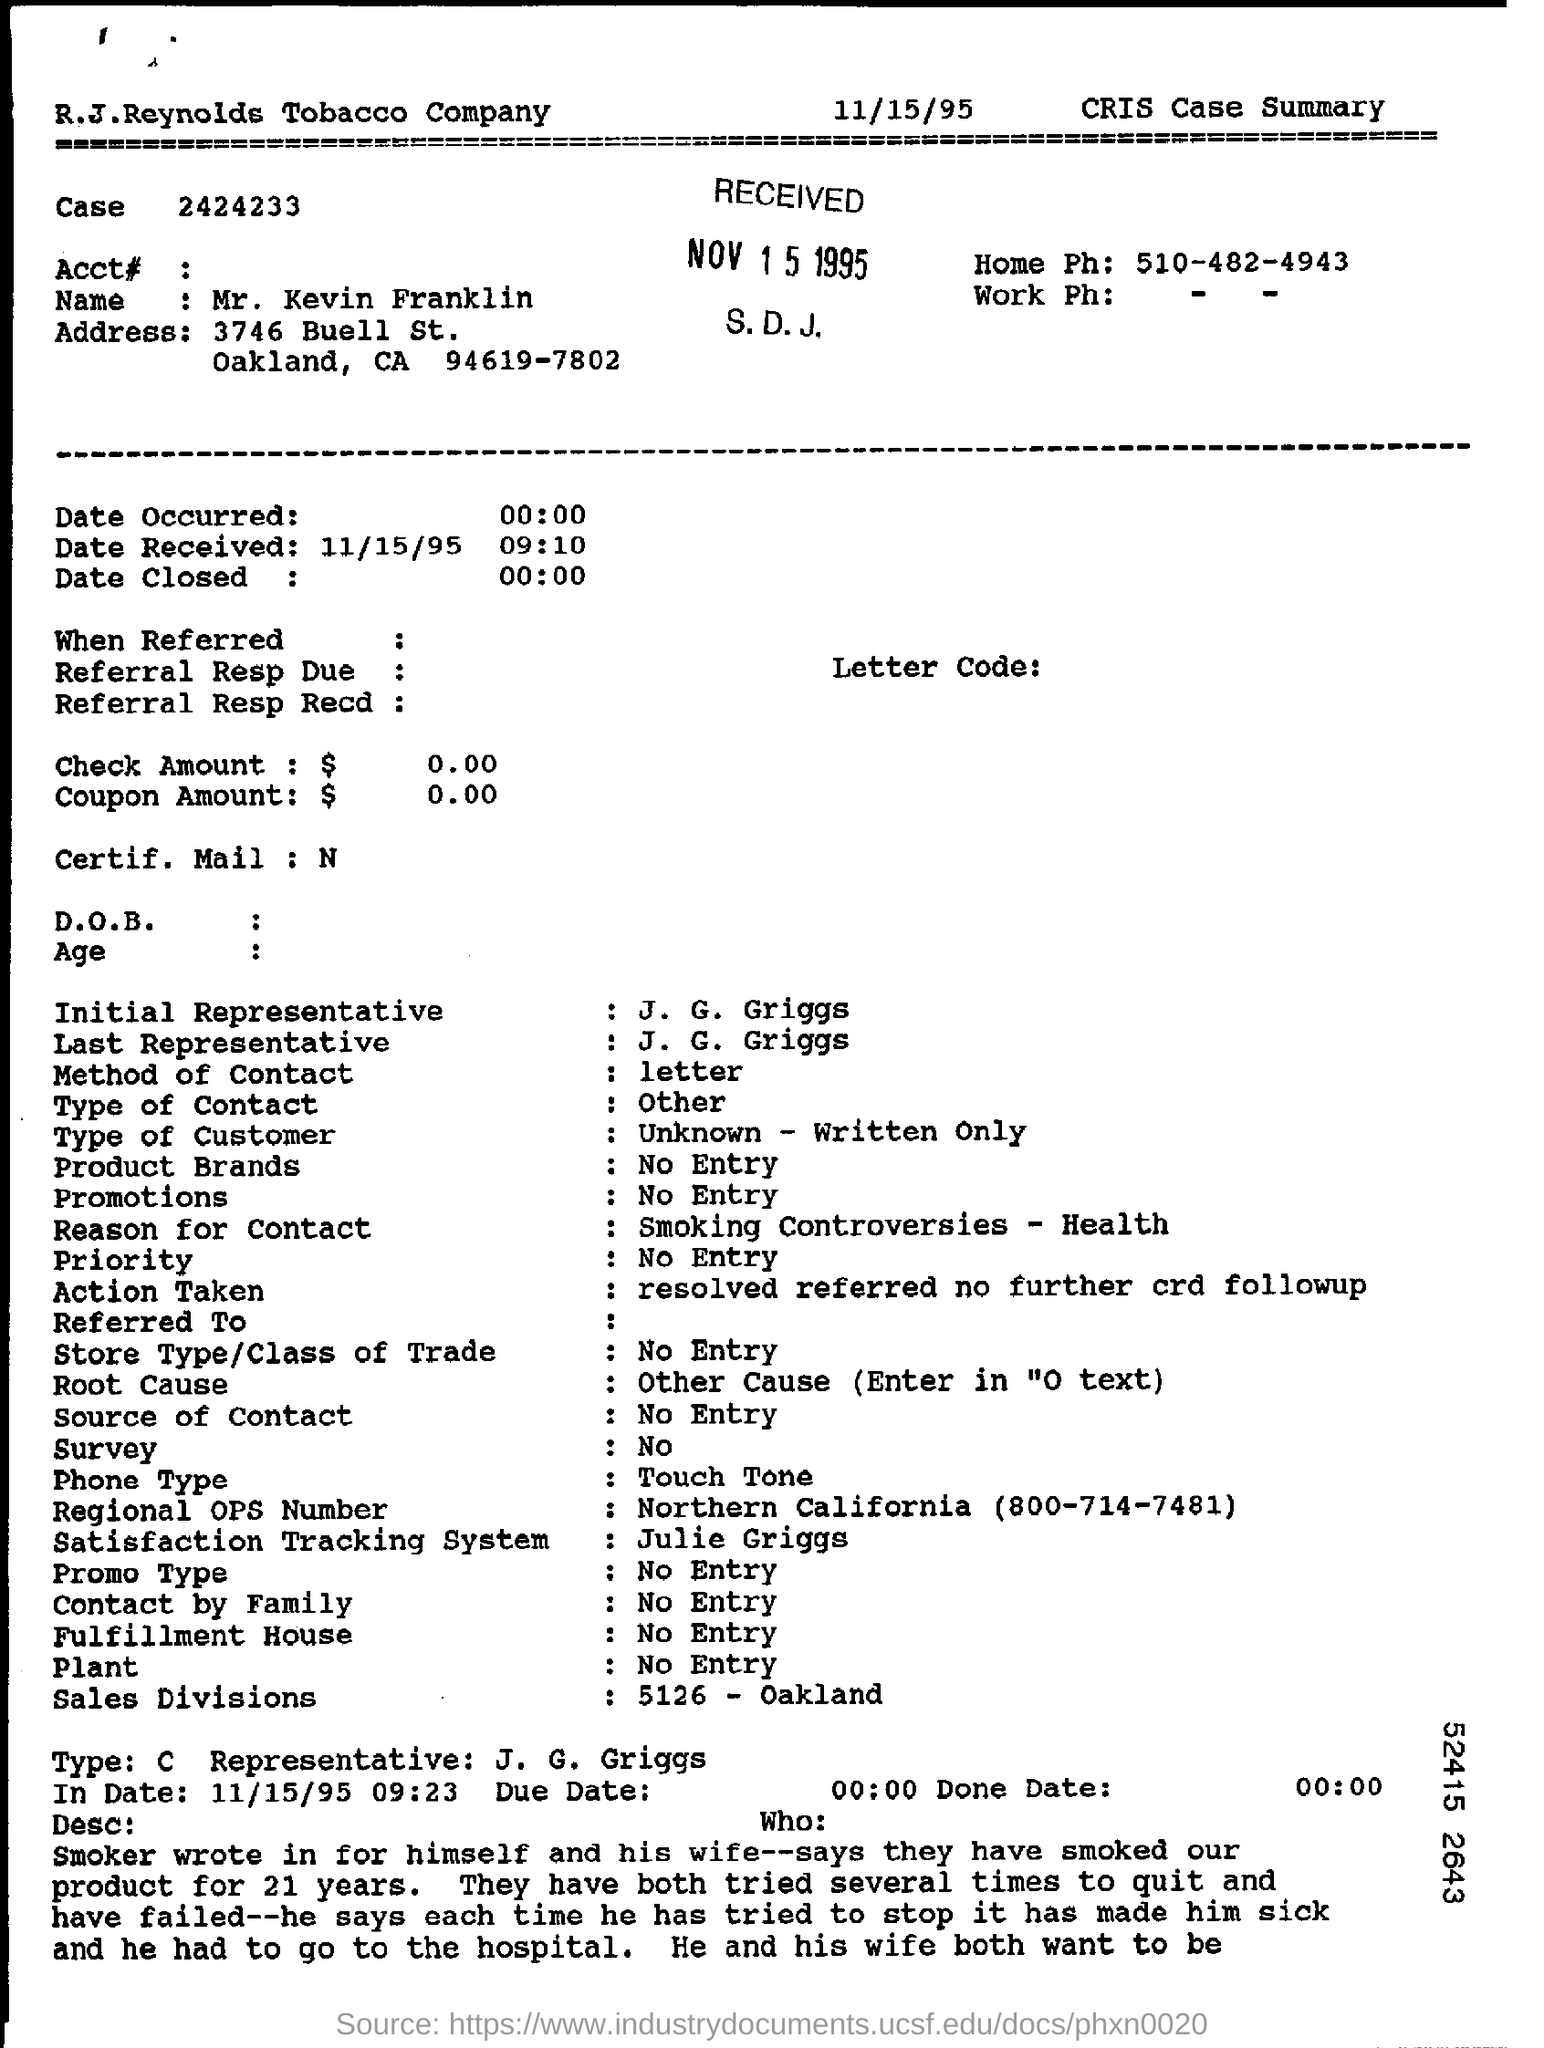What is the number of the case?
Offer a very short reply. 2424233. What is the name in the cris case summary?
Your response must be concise. Mr. Kevin Franklin. What is the stamp date of the received?
Offer a very short reply. NOV 15 1995. Where is the sales division?
Provide a succinct answer. 5126 - Oakland. Who is the type c representative?
Ensure brevity in your answer.  J.G . Griggs. What is the regional ops number?
Provide a succinct answer. Northern California (800-714-7481). 